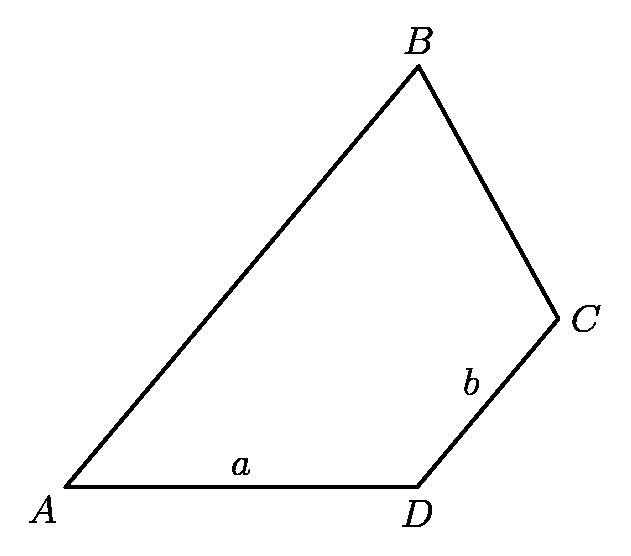Can you explore what relationship might exist between the lengths of AB and CD given that they are parallel? When two segments like AB and CD are parallel in a geometric figure, and assuming there are no additional conditions altering their proportions such as different scaling factors, their lengths might typically represent a direct ratio or equality, dependent on the complete geometric context. However, in practical problems involving parallel lines, the similarity of triangles or trapezoids formed by these lines can also play a critical role in determining the exact relationship between these lengths. In-depth exploration of adjacent angles or constructing auxiliary lines might help further clarify their ratio or proportionality. 